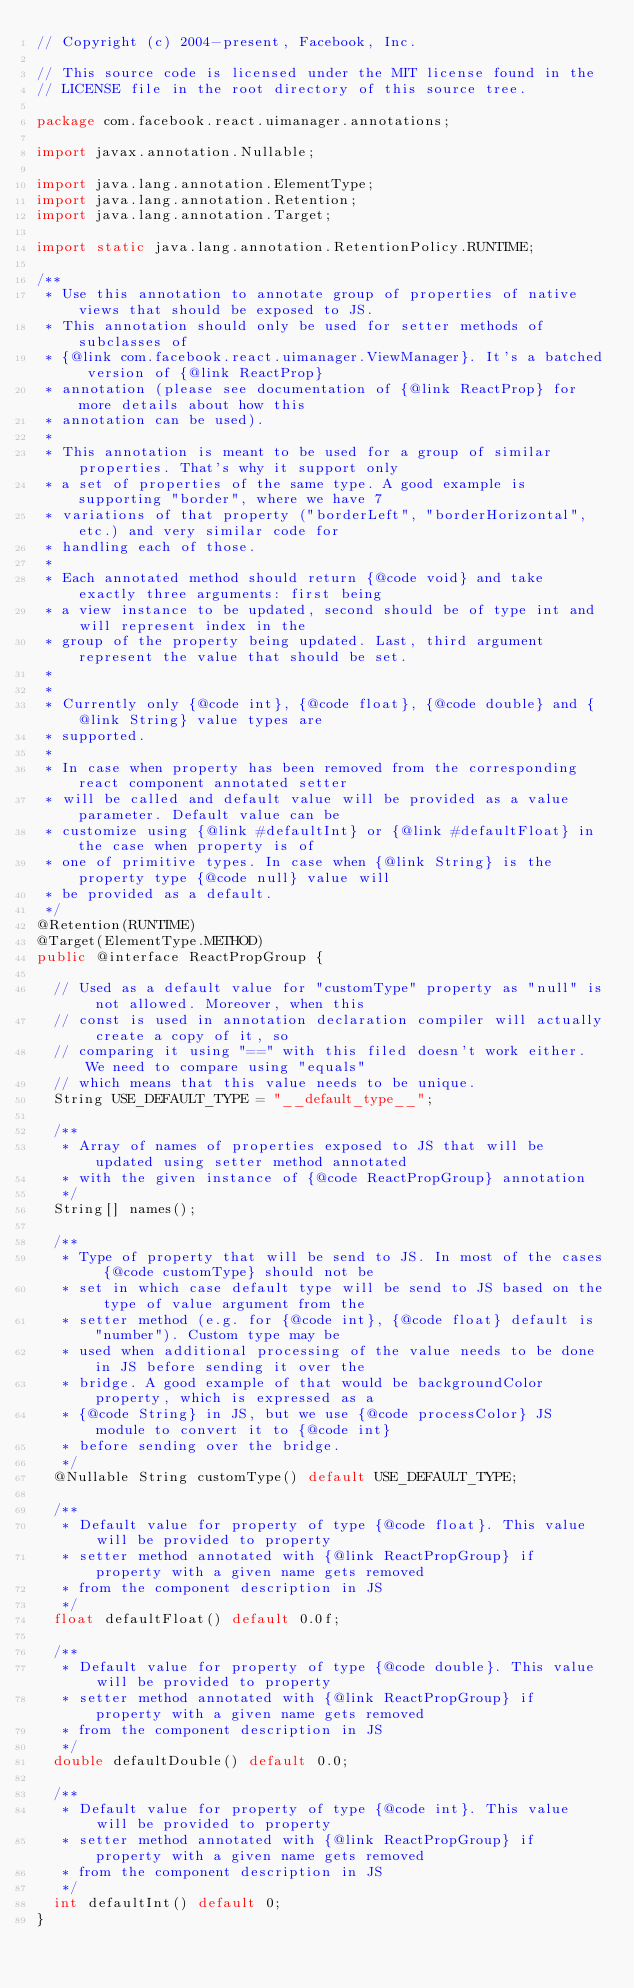Convert code to text. <code><loc_0><loc_0><loc_500><loc_500><_Java_>// Copyright (c) 2004-present, Facebook, Inc.

// This source code is licensed under the MIT license found in the
// LICENSE file in the root directory of this source tree.

package com.facebook.react.uimanager.annotations;

import javax.annotation.Nullable;

import java.lang.annotation.ElementType;
import java.lang.annotation.Retention;
import java.lang.annotation.Target;

import static java.lang.annotation.RetentionPolicy.RUNTIME;

/**
 * Use this annotation to annotate group of properties of native views that should be exposed to JS.
 * This annotation should only be used for setter methods of subclasses of
 * {@link com.facebook.react.uimanager.ViewManager}. It's a batched version of {@link ReactProp}
 * annotation (please see documentation of {@link ReactProp} for more details about how this
 * annotation can be used).
 *
 * This annotation is meant to be used for a group of similar properties. That's why it support only
 * a set of properties of the same type. A good example is supporting "border", where we have 7
 * variations of that property ("borderLeft", "borderHorizontal", etc.) and very similar code for
 * handling each of those.
 *
 * Each annotated method should return {@code void} and take exactly three arguments: first being
 * a view instance to be updated, second should be of type int and will represent index in the
 * group of the property being updated. Last, third argument represent the value that should be set.
 *
 *
 * Currently only {@code int}, {@code float}, {@code double} and {@link String} value types are
 * supported.
 *
 * In case when property has been removed from the corresponding react component annotated setter
 * will be called and default value will be provided as a value parameter. Default value can be
 * customize using {@link #defaultInt} or {@link #defaultFloat} in the case when property is of
 * one of primitive types. In case when {@link String} is the property type {@code null} value will
 * be provided as a default.
 */
@Retention(RUNTIME)
@Target(ElementType.METHOD)
public @interface ReactPropGroup {

  // Used as a default value for "customType" property as "null" is not allowed. Moreover, when this
  // const is used in annotation declaration compiler will actually create a copy of it, so
  // comparing it using "==" with this filed doesn't work either. We need to compare using "equals"
  // which means that this value needs to be unique.
  String USE_DEFAULT_TYPE = "__default_type__";

  /**
   * Array of names of properties exposed to JS that will be updated using setter method annotated
   * with the given instance of {@code ReactPropGroup} annotation
   */
  String[] names();

  /**
   * Type of property that will be send to JS. In most of the cases {@code customType} should not be
   * set in which case default type will be send to JS based on the type of value argument from the
   * setter method (e.g. for {@code int}, {@code float} default is "number"). Custom type may be
   * used when additional processing of the value needs to be done in JS before sending it over the
   * bridge. A good example of that would be backgroundColor property, which is expressed as a
   * {@code String} in JS, but we use {@code processColor} JS module to convert it to {@code int}
   * before sending over the bridge.
   */
  @Nullable String customType() default USE_DEFAULT_TYPE;

  /**
   * Default value for property of type {@code float}. This value will be provided to property
   * setter method annotated with {@link ReactPropGroup} if property with a given name gets removed
   * from the component description in JS
   */
  float defaultFloat() default 0.0f;

  /**
   * Default value for property of type {@code double}. This value will be provided to property
   * setter method annotated with {@link ReactPropGroup} if property with a given name gets removed
   * from the component description in JS
   */
  double defaultDouble() default 0.0;

  /**
   * Default value for property of type {@code int}. This value will be provided to property
   * setter method annotated with {@link ReactPropGroup} if property with a given name gets removed
   * from the component description in JS
   */
  int defaultInt() default 0;
}
</code> 